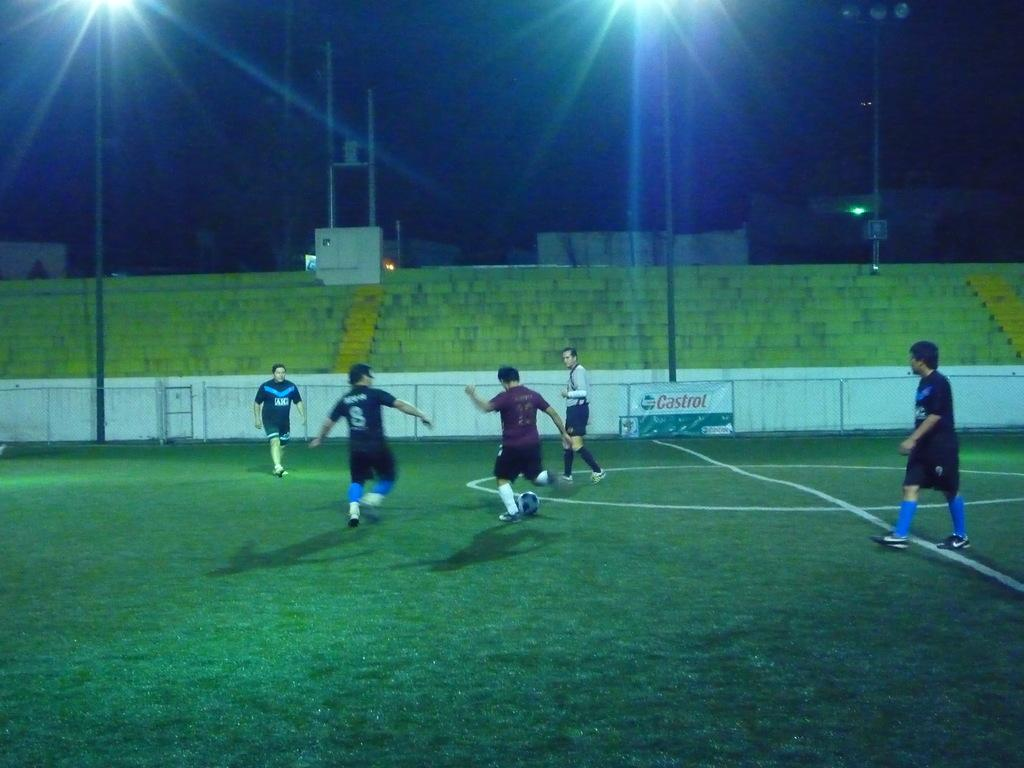<image>
Offer a succinct explanation of the picture presented. Men play soccer on a field which has a Castrol banner in the background. 